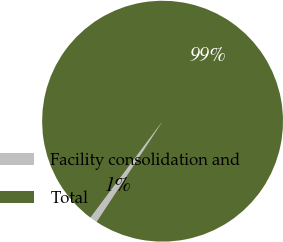Convert chart. <chart><loc_0><loc_0><loc_500><loc_500><pie_chart><fcel>Facility consolidation and<fcel>Total<nl><fcel>0.99%<fcel>99.01%<nl></chart> 